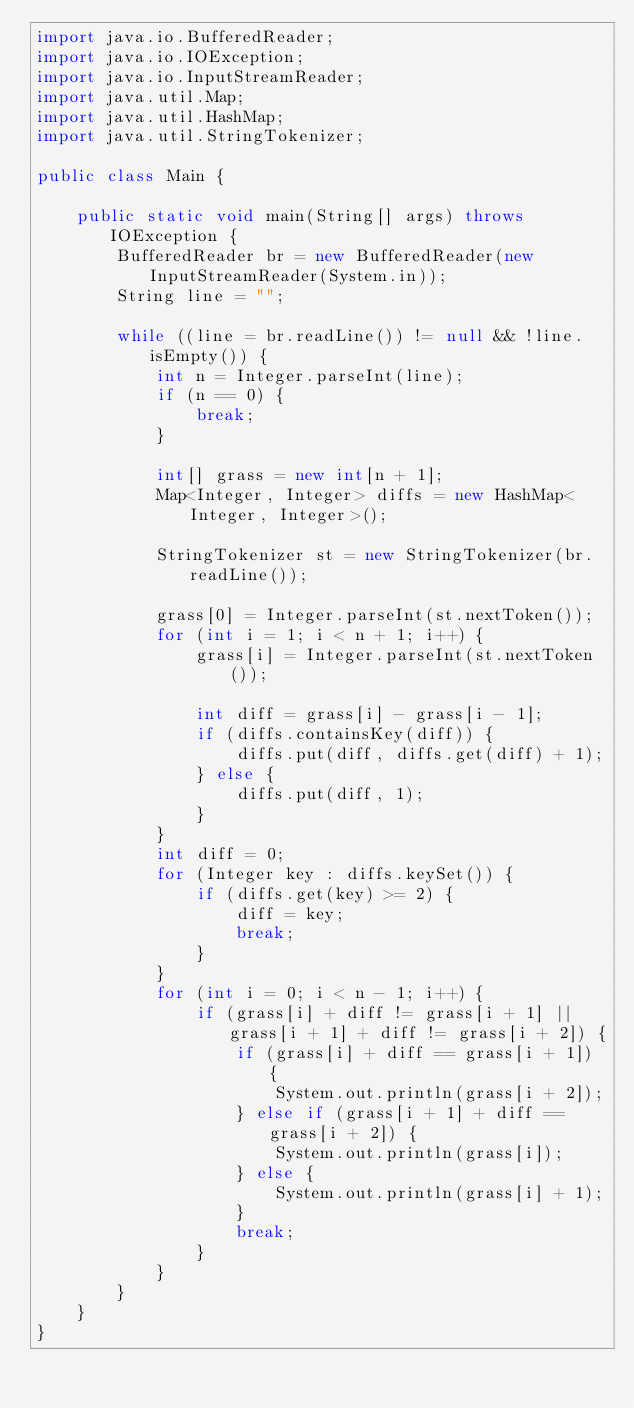Convert code to text. <code><loc_0><loc_0><loc_500><loc_500><_Java_>import java.io.BufferedReader;
import java.io.IOException;
import java.io.InputStreamReader;
import java.util.Map;
import java.util.HashMap;
import java.util.StringTokenizer;

public class Main {

	public static void main(String[] args) throws IOException {
		BufferedReader br = new BufferedReader(new InputStreamReader(System.in));
		String line = "";

		while ((line = br.readLine()) != null && !line.isEmpty()) {
			int n = Integer.parseInt(line);
			if (n == 0) {
				break;
			}

			int[] grass = new int[n + 1];
			Map<Integer, Integer> diffs = new HashMap<Integer, Integer>();

			StringTokenizer st = new StringTokenizer(br.readLine());

			grass[0] = Integer.parseInt(st.nextToken());
			for (int i = 1; i < n + 1; i++) {
				grass[i] = Integer.parseInt(st.nextToken());

				int diff = grass[i] - grass[i - 1];
				if (diffs.containsKey(diff)) {
					diffs.put(diff, diffs.get(diff) + 1);
				} else {
					diffs.put(diff, 1);
				}
			}
			int diff = 0;
			for (Integer key : diffs.keySet()) {
				if (diffs.get(key) >= 2) {
					diff = key;
					break;
				}
			}
			for (int i = 0; i < n - 1; i++) {
				if (grass[i] + diff != grass[i + 1] || grass[i + 1] + diff != grass[i + 2]) {
					if (grass[i] + diff == grass[i + 1]) {
						System.out.println(grass[i + 2]);
					} else if (grass[i + 1] + diff == grass[i + 2]) {
						System.out.println(grass[i]);
					} else {
						System.out.println(grass[i] + 1);
					}
					break;
				}
			}
		}
	}
}</code> 